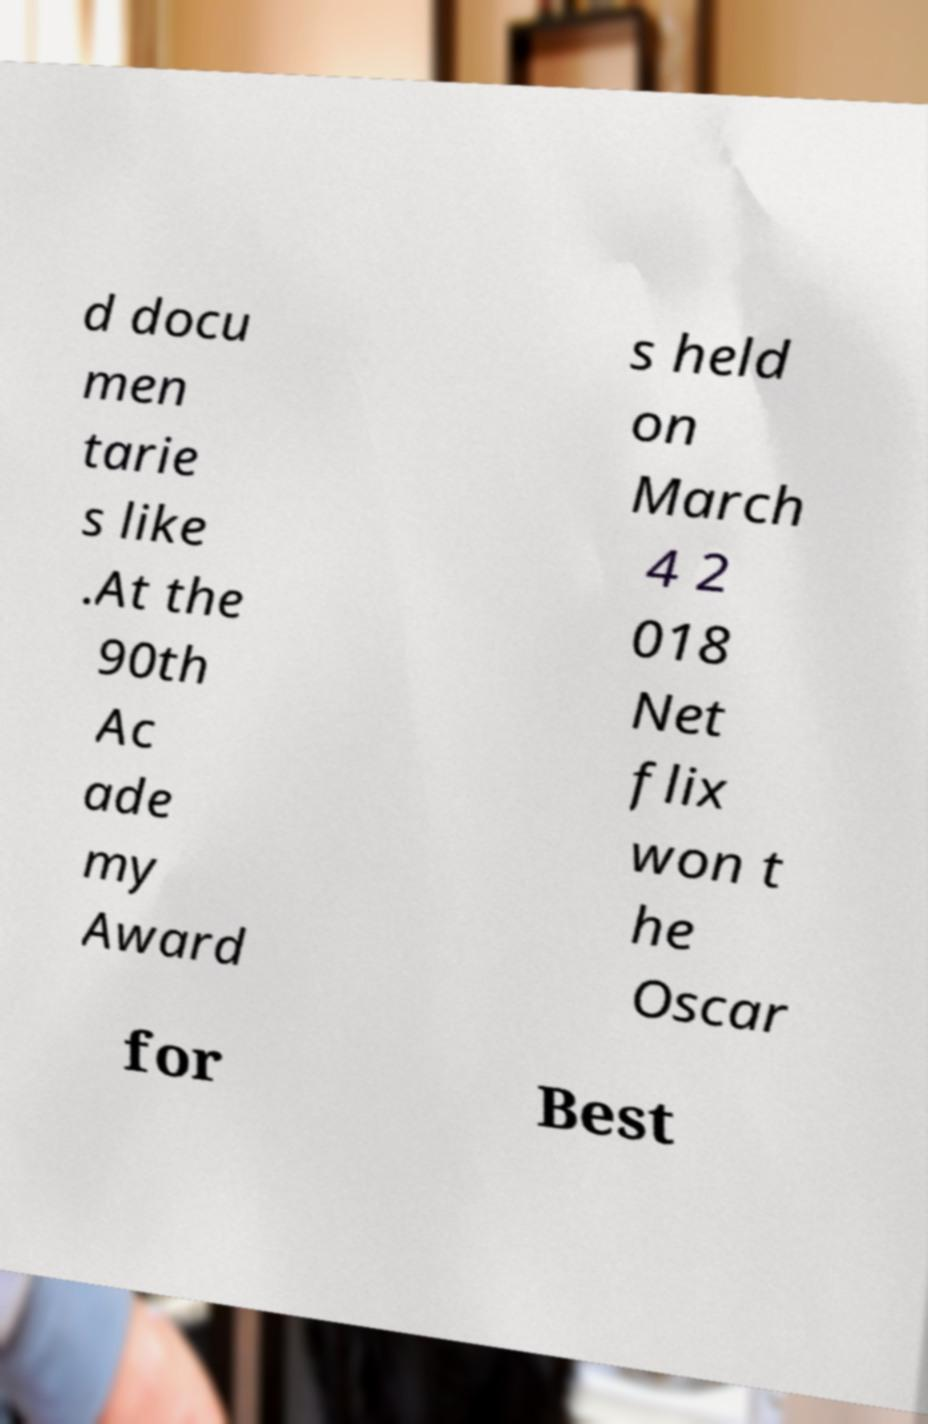Could you assist in decoding the text presented in this image and type it out clearly? d docu men tarie s like .At the 90th Ac ade my Award s held on March 4 2 018 Net flix won t he Oscar for Best 